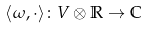<formula> <loc_0><loc_0><loc_500><loc_500>\langle \omega , \cdot \rangle \colon V \otimes \mathbb { R } \rightarrow \mathbb { C }</formula> 